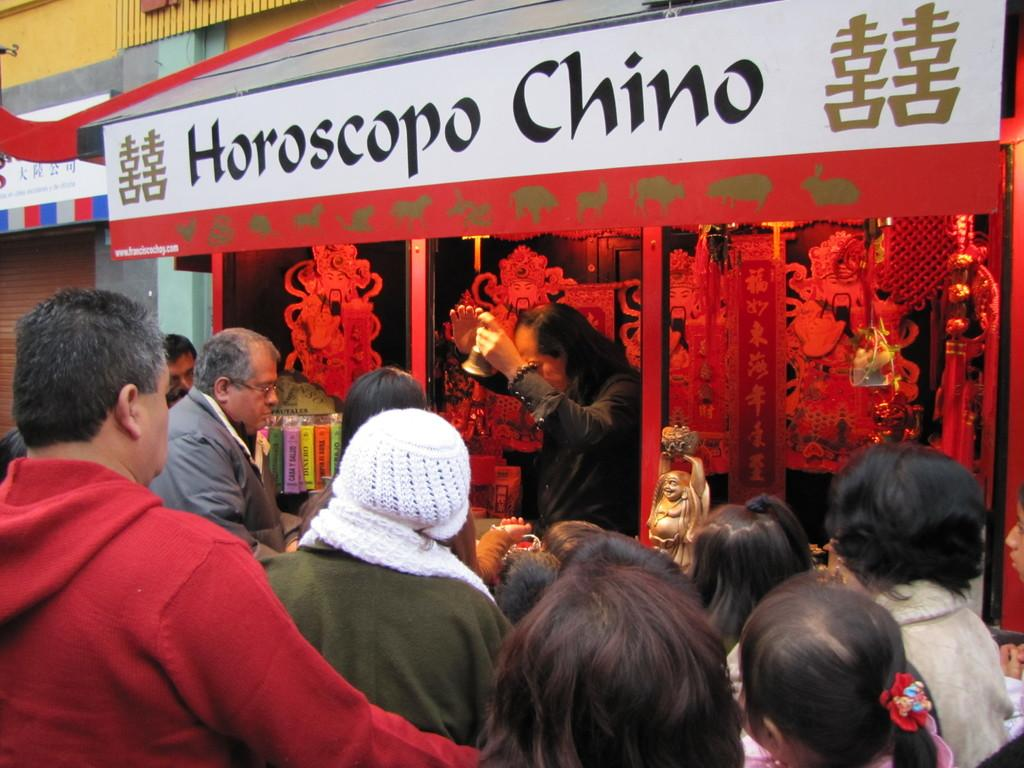What type of structure is visible in the image? There is a building in the image. What type of establishment can be found within the building? There is a store in the image. Are there any people present in the image? Yes, there are people standing in the image. What is the man holding in his hand? The man is holding a bell in his hand. What other object can be seen in the image? There is a statue in the image. Is there any text visible in the image? Yes, there is a Board with some text in the image. How many sisters are standing next to the statue in the image? There is no mention of sisters in the image, nor is there any indication of their presence. 